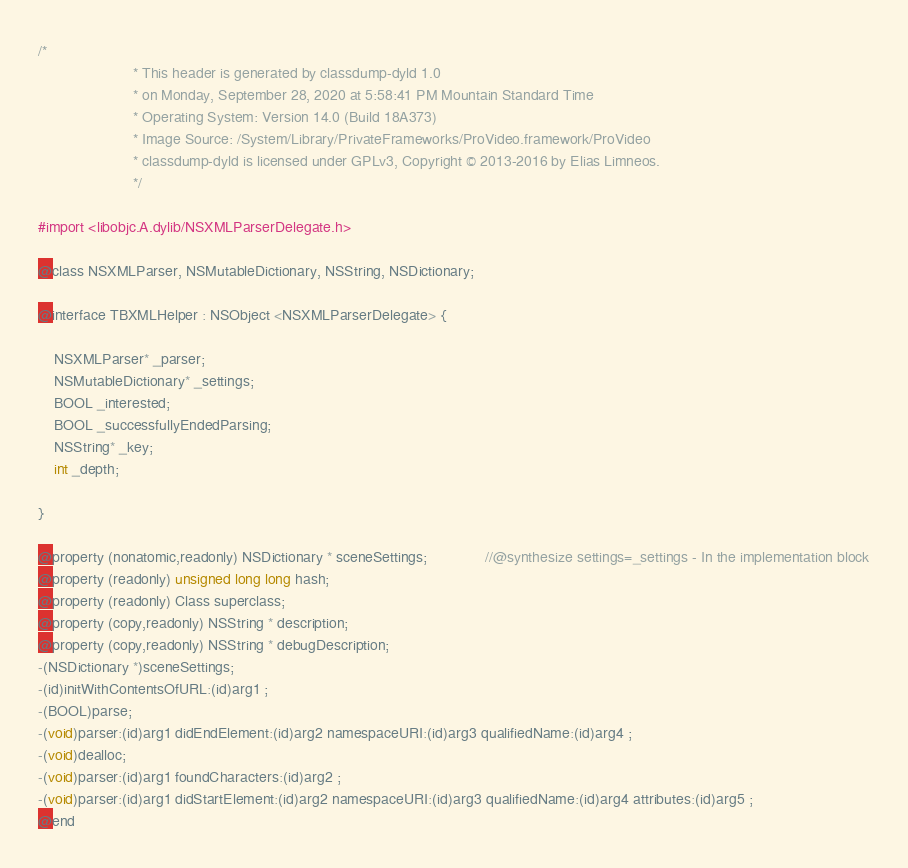Convert code to text. <code><loc_0><loc_0><loc_500><loc_500><_C_>/*
                       * This header is generated by classdump-dyld 1.0
                       * on Monday, September 28, 2020 at 5:58:41 PM Mountain Standard Time
                       * Operating System: Version 14.0 (Build 18A373)
                       * Image Source: /System/Library/PrivateFrameworks/ProVideo.framework/ProVideo
                       * classdump-dyld is licensed under GPLv3, Copyright © 2013-2016 by Elias Limneos.
                       */

#import <libobjc.A.dylib/NSXMLParserDelegate.h>

@class NSXMLParser, NSMutableDictionary, NSString, NSDictionary;

@interface TBXMLHelper : NSObject <NSXMLParserDelegate> {

	NSXMLParser* _parser;
	NSMutableDictionary* _settings;
	BOOL _interested;
	BOOL _successfullyEndedParsing;
	NSString* _key;
	int _depth;

}

@property (nonatomic,readonly) NSDictionary * sceneSettings;              //@synthesize settings=_settings - In the implementation block
@property (readonly) unsigned long long hash; 
@property (readonly) Class superclass; 
@property (copy,readonly) NSString * description; 
@property (copy,readonly) NSString * debugDescription; 
-(NSDictionary *)sceneSettings;
-(id)initWithContentsOfURL:(id)arg1 ;
-(BOOL)parse;
-(void)parser:(id)arg1 didEndElement:(id)arg2 namespaceURI:(id)arg3 qualifiedName:(id)arg4 ;
-(void)dealloc;
-(void)parser:(id)arg1 foundCharacters:(id)arg2 ;
-(void)parser:(id)arg1 didStartElement:(id)arg2 namespaceURI:(id)arg3 qualifiedName:(id)arg4 attributes:(id)arg5 ;
@end

</code> 